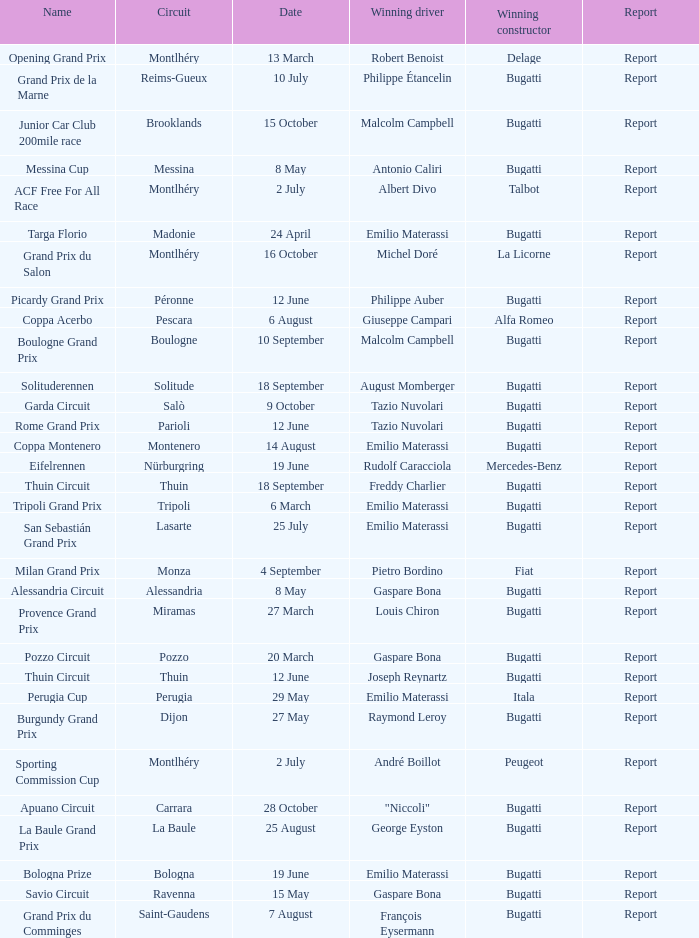Which circuit did françois eysermann win ? Saint-Gaudens. 